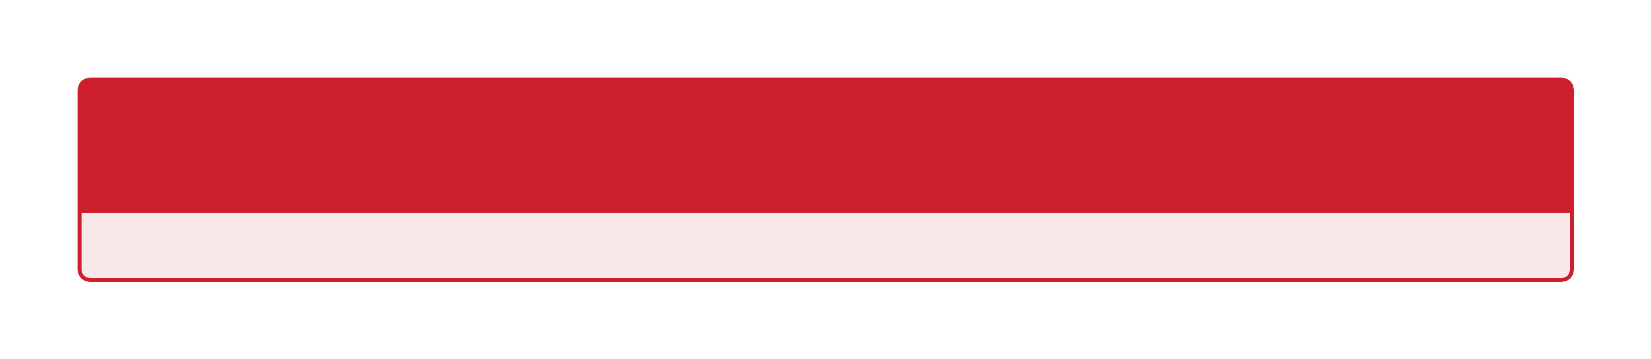Who is the composer for the 1970s? The composer listed for the 1970s in the document is R.D. Burman.
Answer: R.D. Burman What is a notable song from the 1990s? The notable song from the 1990s mentioned in the document is "Tujhe Dekha To."
Answer: Tujhe Dekha To Which singer is associated with the 2010s soundtracks? The singers associated with the 2010s are Ranveer Singh, Divine.
Answer: Ranveer Singh, Divine What year is mentioned for the 1980s? The document states that the year for the 1980s is 1988.
Answer: 1988 What is the title of the collection? The title of the collection is "Iconic Bollywood Soundtracks Through the Decades."
Answer: Iconic Bollywood Soundtracks Through the Decades How many decades are covered in the collection? The document covers a total of six decades.
Answer: Six What song represents the 1960s? The song that represents the 1960s is "Pyar Kiya To Darna Kya."
Answer: Pyar Kiya To Darna Kya Who is the composer for the 2000s? The composer listed for the 2000s is A.R. Rahman.
Answer: A.R. Rahman What is the significance of the collection? The collection highlights the evolution of Bollywood music and its impact on popular culture.
Answer: Evolution of Bollywood music 